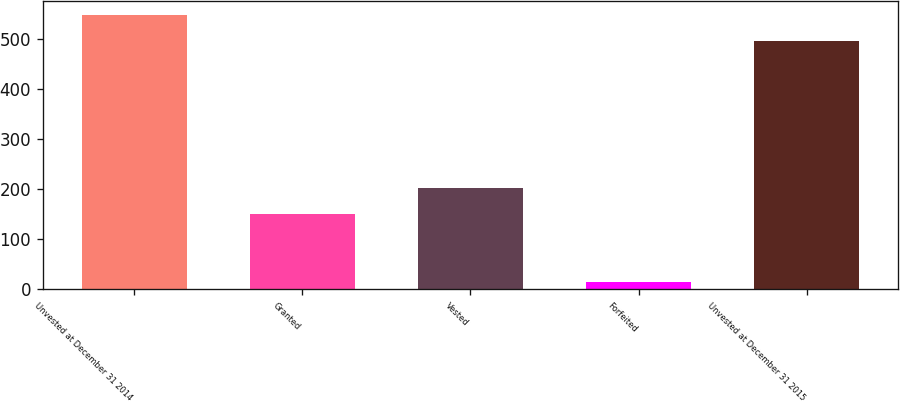Convert chart. <chart><loc_0><loc_0><loc_500><loc_500><bar_chart><fcel>Unvested at December 31 2014<fcel>Granted<fcel>Vested<fcel>Forfeited<fcel>Unvested at December 31 2015<nl><fcel>548.9<fcel>150<fcel>201.9<fcel>14<fcel>497<nl></chart> 